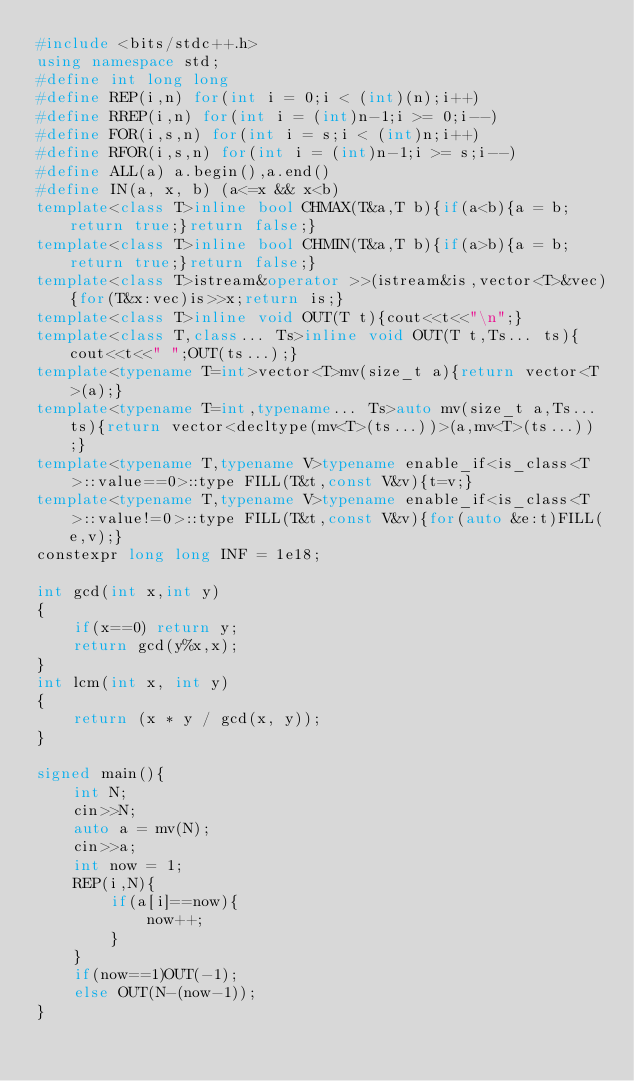Convert code to text. <code><loc_0><loc_0><loc_500><loc_500><_C++_>#include <bits/stdc++.h>
using namespace std;
#define int long long
#define REP(i,n) for(int i = 0;i < (int)(n);i++)
#define RREP(i,n) for(int i = (int)n-1;i >= 0;i--)
#define FOR(i,s,n) for(int i = s;i < (int)n;i++)
#define RFOR(i,s,n) for(int i = (int)n-1;i >= s;i--)
#define ALL(a) a.begin(),a.end()
#define IN(a, x, b) (a<=x && x<b)
template<class T>inline bool CHMAX(T&a,T b){if(a<b){a = b;return true;}return false;}
template<class T>inline bool CHMIN(T&a,T b){if(a>b){a = b;return true;}return false;}
template<class T>istream&operator >>(istream&is,vector<T>&vec){for(T&x:vec)is>>x;return is;}
template<class T>inline void OUT(T t){cout<<t<<"\n";}
template<class T,class... Ts>inline void OUT(T t,Ts... ts){cout<<t<<" ";OUT(ts...);}
template<typename T=int>vector<T>mv(size_t a){return vector<T>(a);}
template<typename T=int,typename... Ts>auto mv(size_t a,Ts... ts){return vector<decltype(mv<T>(ts...))>(a,mv<T>(ts...));}
template<typename T,typename V>typename enable_if<is_class<T>::value==0>::type FILL(T&t,const V&v){t=v;}
template<typename T,typename V>typename enable_if<is_class<T>::value!=0>::type FILL(T&t,const V&v){for(auto &e:t)FILL(e,v);}
constexpr long long INF = 1e18;

int gcd(int x,int y)
{
	if(x==0) return y;
	return gcd(y%x,x);
}
int lcm(int x, int y)
{
	return (x * y / gcd(x, y));
}

signed main(){
	int N;
	cin>>N;
	auto a = mv(N);
	cin>>a;
	int now = 1;
	REP(i,N){
		if(a[i]==now){
			now++;
		}
	}
	if(now==1)OUT(-1);
	else OUT(N-(now-1));
}</code> 